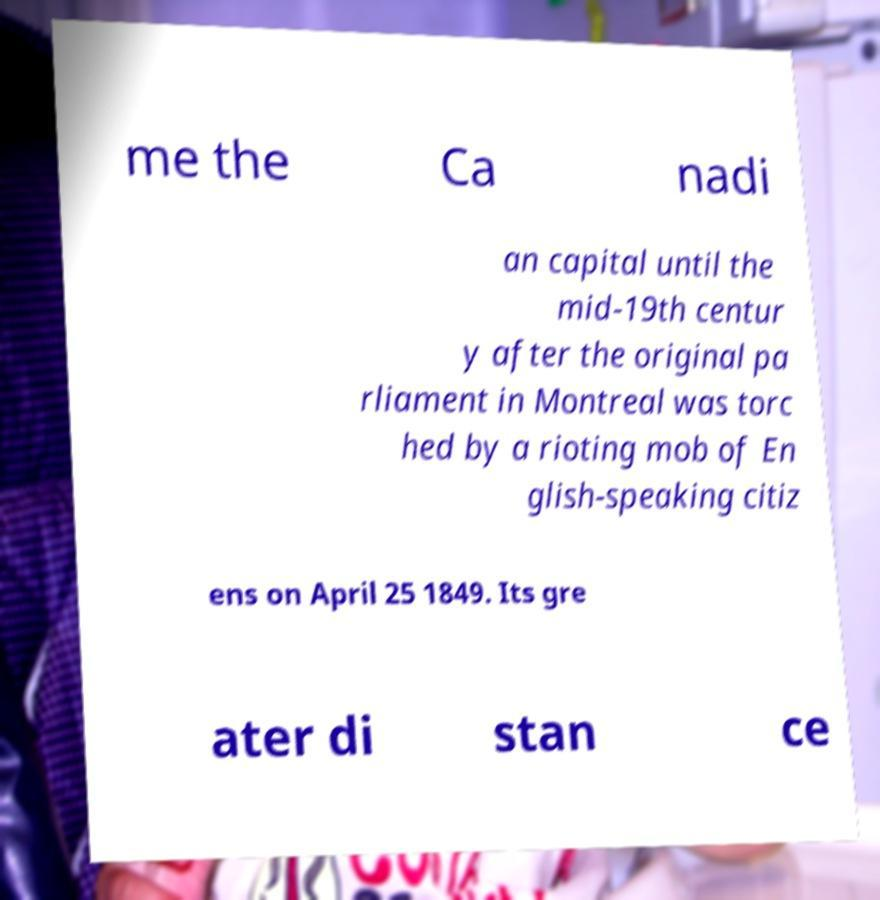Please identify and transcribe the text found in this image. me the Ca nadi an capital until the mid-19th centur y after the original pa rliament in Montreal was torc hed by a rioting mob of En glish-speaking citiz ens on April 25 1849. Its gre ater di stan ce 